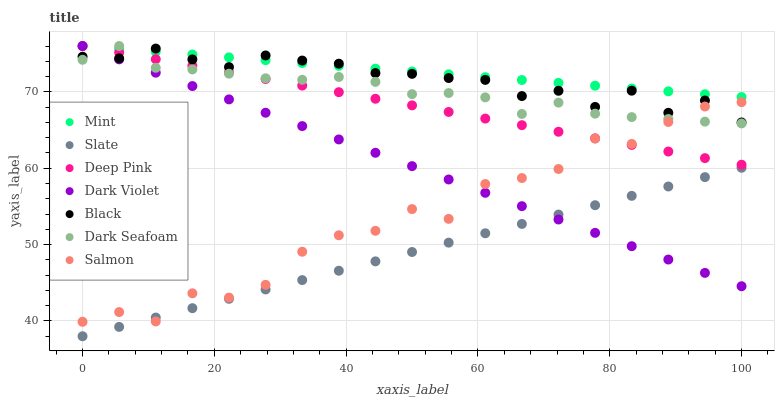Does Slate have the minimum area under the curve?
Answer yes or no. Yes. Does Mint have the maximum area under the curve?
Answer yes or no. Yes. Does Salmon have the minimum area under the curve?
Answer yes or no. No. Does Salmon have the maximum area under the curve?
Answer yes or no. No. Is Dark Violet the smoothest?
Answer yes or no. Yes. Is Salmon the roughest?
Answer yes or no. Yes. Is Slate the smoothest?
Answer yes or no. No. Is Slate the roughest?
Answer yes or no. No. Does Slate have the lowest value?
Answer yes or no. Yes. Does Salmon have the lowest value?
Answer yes or no. No. Does Mint have the highest value?
Answer yes or no. Yes. Does Salmon have the highest value?
Answer yes or no. No. Is Slate less than Mint?
Answer yes or no. Yes. Is Dark Seafoam greater than Slate?
Answer yes or no. Yes. Does Salmon intersect Deep Pink?
Answer yes or no. Yes. Is Salmon less than Deep Pink?
Answer yes or no. No. Is Salmon greater than Deep Pink?
Answer yes or no. No. Does Slate intersect Mint?
Answer yes or no. No. 